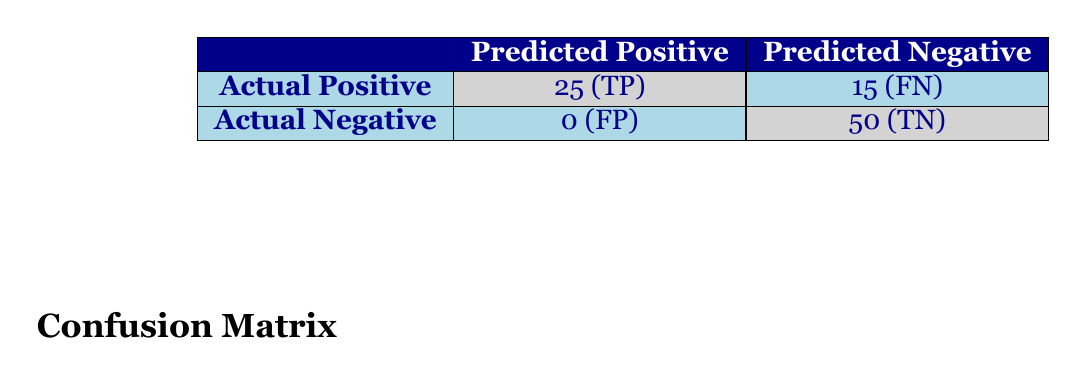What is the number of true positives (TP) in the confusion matrix? The confusion matrix shows that the number of true positives (TP) is indicated in the cell corresponding to Actual Positive and Predicted Positive, which is 25.
Answer: 25 What is the total number of participants who reported no change after the workshops? To find this, we look at the "no_change" values from each workshop: 5 (Labor Rights Basics) + 5 (Union Organizing Strategies) + 5 (Understanding Collective Bargaining) + 5 (Worker's Rights Protection) + 10 (Legal Frameworks for Activism) = 30.
Answer: 30 Is there any workshop that resulted in false positives (FP)? The confusion matrix indicates false positives (FP) as 0, meaning there were no instances where participants reported knowledge gains when they actually had no change.
Answer: No What is the total number of actual negatives (TN + FP)? From the confusion matrix, actual negatives consist of true negatives (TN) + false positives (FP), which is 50 (TN) + 0 (FP) = 50.
Answer: 50 What proportion of participants experienced knowledge gains across all workshops? First, sum the knowledge gains: 25 + 15 + 20 + 10 + 30 = 100. Then divide by the total participants: 30 + 20 + 25 + 15 + 40 = 130. The proportion is 100/130, which simplifies to approximately 0.769 or 76.9%.
Answer: 76.9% If 15 participants did not report knowledge gains, how many participants were positively impacted by the workshops? The number of positively impacted participants is the total number of participants (130) minus those who reported no change (15): 130 - 15 = 115.
Answer: 115 What is the ratio of true negatives to true positives? The confusion matrix indicates TN as 50 and TP as 25. The ratio is calculated by dividing TN by TP: 50/25 = 2.
Answer: 2 Did all workshops have a predominant number of participants reporting knowledge gains? To check this, we see if knowledge gains are greater than no change for each workshop. All workshops show more knowledge gains than no change, confirming a predominant positive effect.
Answer: Yes 